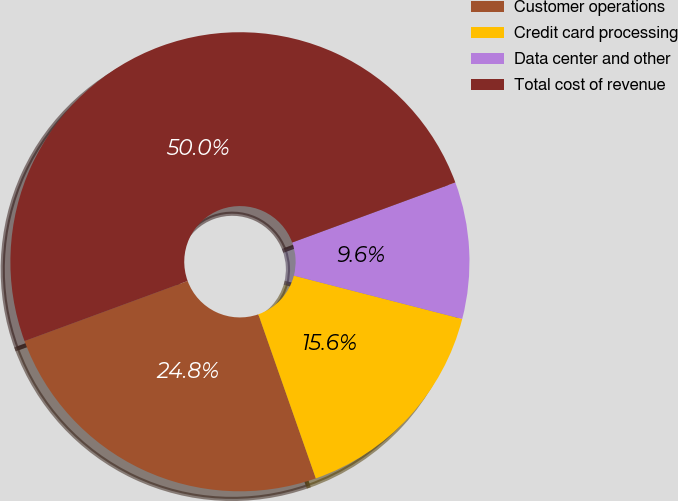<chart> <loc_0><loc_0><loc_500><loc_500><pie_chart><fcel>Customer operations<fcel>Credit card processing<fcel>Data center and other<fcel>Total cost of revenue<nl><fcel>24.75%<fcel>15.63%<fcel>9.62%<fcel>50.0%<nl></chart> 